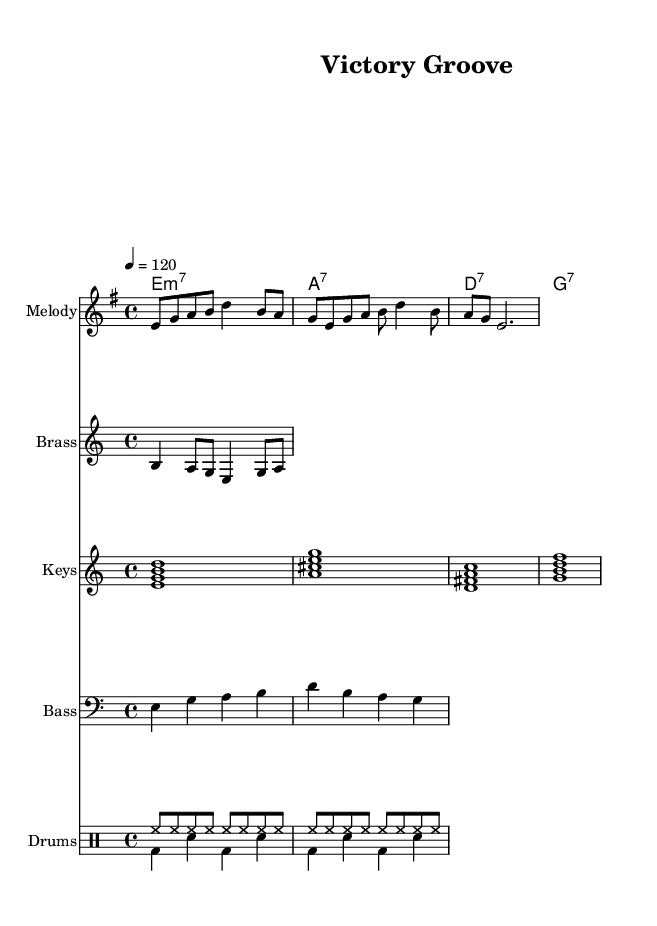What is the key signature of this music? The key signature is E minor, which is indicated by one sharp (F#). This can be determined by looking at the key signature symbol at the beginning of the score.
Answer: E minor What is the time signature of this music? The time signature is 4/4, shown at the beginning of the score. This means there are four beats per measure, and the quarter note gets one beat.
Answer: 4/4 What is the tempo marking for this piece? The tempo marking is 120, which indicates the beats per minute (BPM). This value is noted in the tempo directive at the beginning of the score.
Answer: 120 How many sections does the melody have? The melody has three distinct sections, identifiable by their phrasing and note lengths. Each section features a unique combination of notes within the bars.
Answer: 3 What type of chords are used in the harmonies? The chords are minor 7th and dominant 7th chords. This conclusion is drawn from the chord symbols which include "m7" and "7" next to the chord names.
Answer: minor 7th and dominant 7th How would you describe the rhythm used in the drums? The rhythm alternates between the hi-hat and bass drum with a consistent eighth note pattern for the hi-hat and a syncopated pattern for the bass drum. This creates a typical funk groove.
Answer: syncopated and consistent What instruments are presented in the score? The score includes a melody, brass, piano, bass, and drums. Looking at the staff labels reveals the names of the instruments used in the arrangement.
Answer: Melody, Brass, Keys, Bass, Drums 